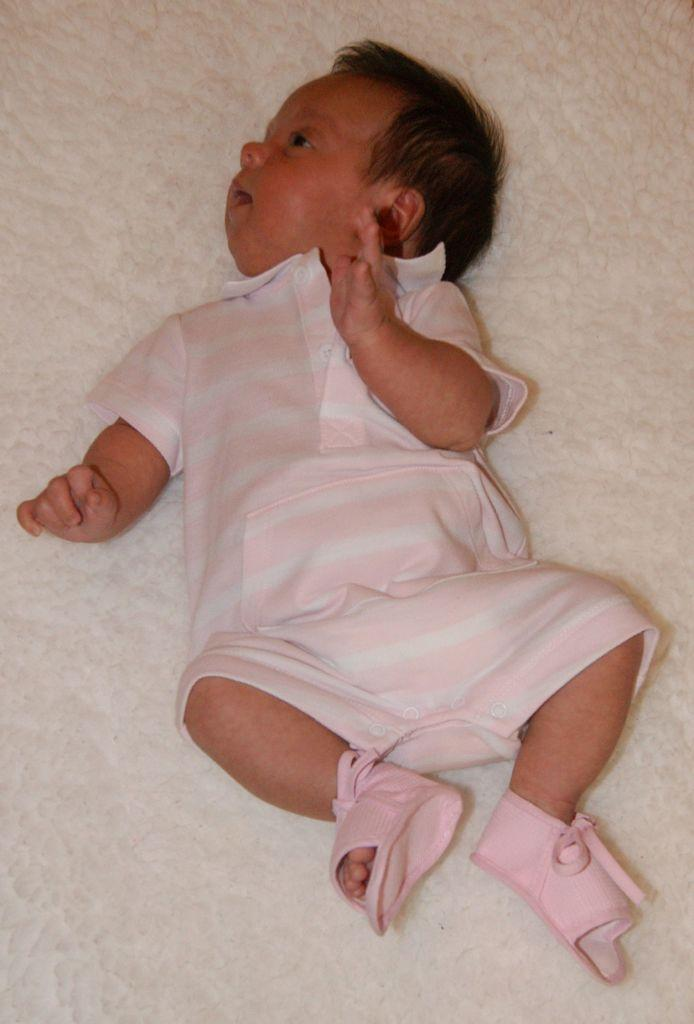What is the main subject of the image? The main subject of the image is a baby. Where is the baby located in the image? The baby is lying on a mattress. What is the weight of the fireman in the image? There is no fireman present in the image, so it is not possible to determine their weight. 